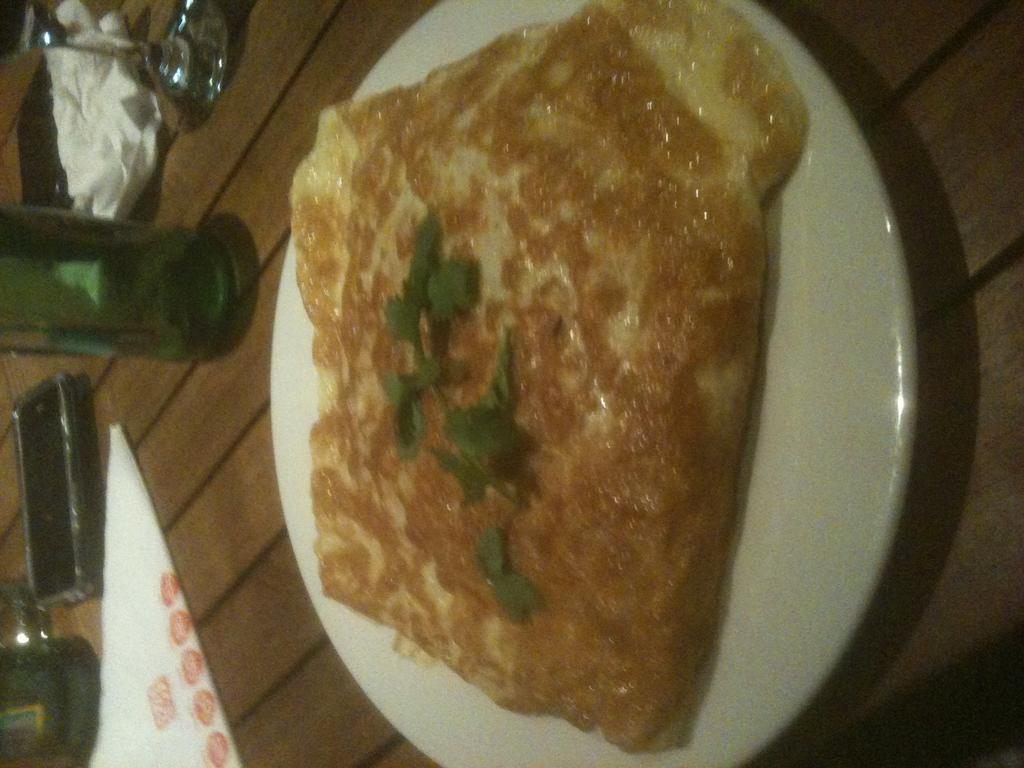What is the main subject of the image? There is a food item in the image. How is the food item presented in the image? The food item is in a plate. What else can be seen on the table in the image? There is a bottle on the table in the image. How many bees are buzzing around the food item in the image? There are no bees present in the image. What type of birds can be seen flying near the food item in the image? There are no birds present in the image. 